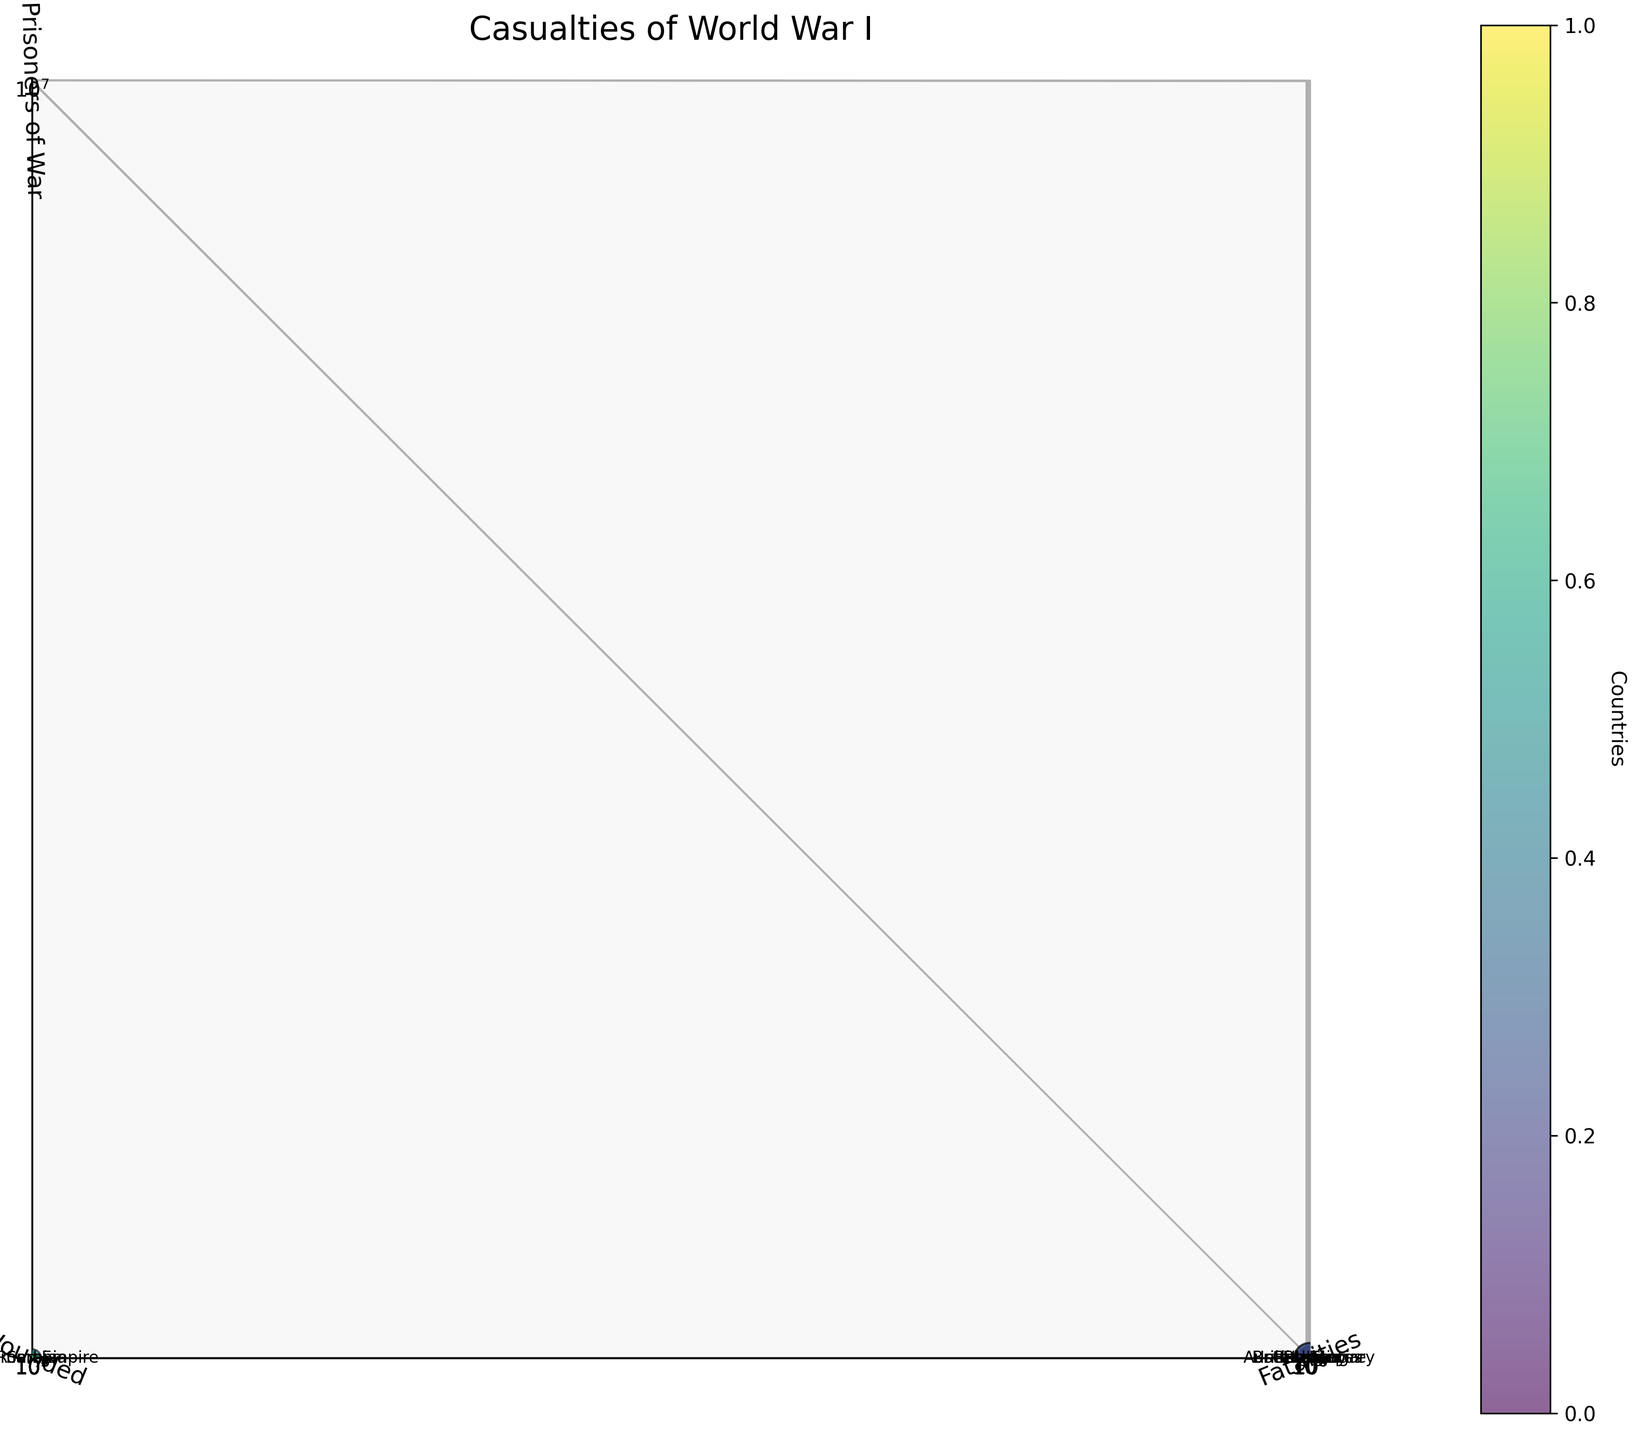What is the title of the chart? The title is displayed at the top of the chart. It reads "Casualties of World War I".
Answer: Casualties of World War I Which country has the highest number of fatalities? By looking at the Fatalities axis and identifying the highest bubble position, we see that Russia has the highest number of fatalities.
Answer: Russia Which country has the lowest number of prisoners of war? By examining the Prisoners of War axis and finding the smallest bubble position, we see that the United States has the lowest number.
Answer: United States Which countries have more than one million wounded? A country has more than one million wounded if the bubble is situated above the 1 million mark on the Wounded axis. These countries are France, Germany, Russia, Austria-Hungary, and British Empire.
Answer: France, Germany, Russia, Austria-Hungary, British Empire Estimate the ratio of prisoners of war to fatalities for Germany. Is it higher or lower compared to France? For Germany, the ratio is calculated as Prisoners of War/Fatalities = 1152800/2050897 ≈ 0.56 . For France, it is 537000/1375800 ≈ 0.39. Hence, Germany has a higher ratio.
Answer: Higher What is the relationship between the size of the bubbles and the countries’ fatalities? The size of the bubbles represents the number of fatalities; a larger bubble indicates more fatalities. The scale on the Fatalities axis helps correlate bubble size with fatalities.
Answer: Larger bubble, more fatalities Which country has the highest number of wounded? Reading along the Wounded axis and identifying the highest bubble, we see that Russia has the highest number of wounded.
Answer: Russia Compare the number of prisoners of war between Italy and Austria-Hungary. Which country had more? By comparing the positions on the Prisoners of War axis, Austria-Hungary had more prisoners of war than Italy.
Answer: Austria-Hungary Is there any country with fewer than 100,000 fatalities but more than 100,000 prisoners of war? We look for bubbles with less than 100,000 on the Fatalities axis and more than 100,000 on the Prisoners of War axis. Only Bulgaria fits this criterion.
Answer: Bulgaria Based on the log scale, how does the positioning of Serbia appear in terms of fatalities and wounded compared to the other countries? On the log scale, Serbia appears lower both in terms of fatalities and wounded compared to most other countries. It indicates they had fewer casualties and wounded in relative terms.
Answer: Lower 